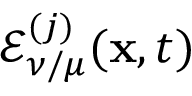<formula> <loc_0><loc_0><loc_500><loc_500>\mathcal { E } _ { \nu / \mu } ^ { ( j ) } ( x , t )</formula> 